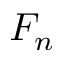Convert formula to latex. <formula><loc_0><loc_0><loc_500><loc_500>F _ { n }</formula> 